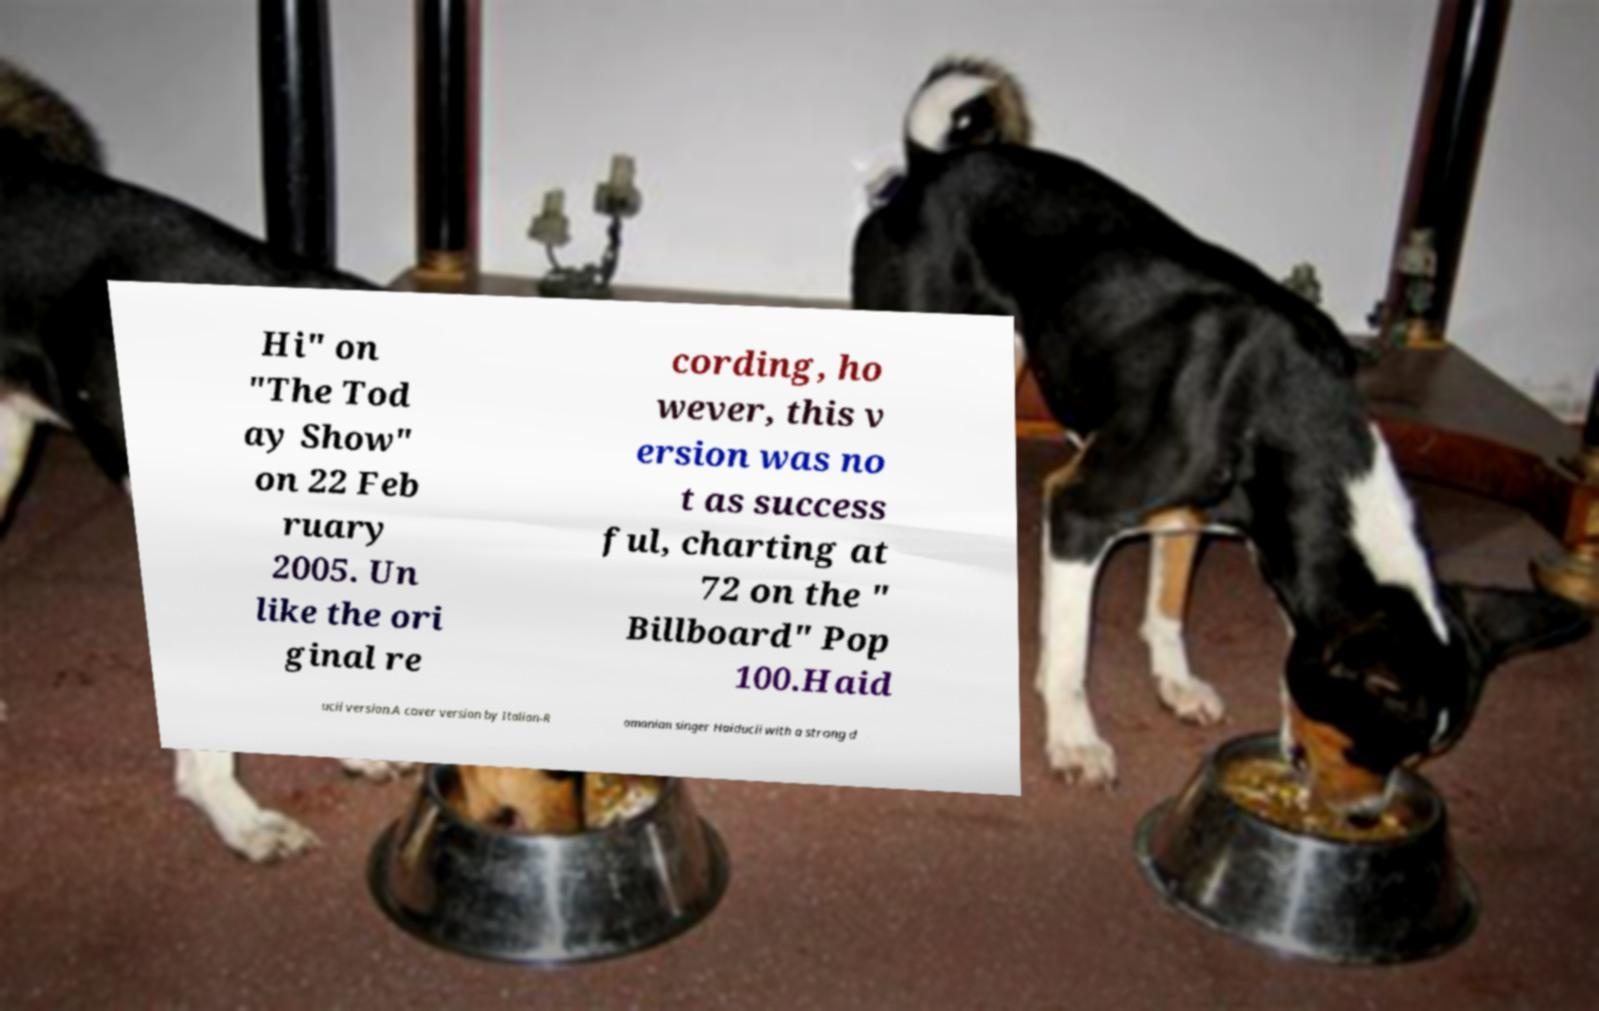There's text embedded in this image that I need extracted. Can you transcribe it verbatim? Hi" on "The Tod ay Show" on 22 Feb ruary 2005. Un like the ori ginal re cording, ho wever, this v ersion was no t as success ful, charting at 72 on the " Billboard" Pop 100.Haid ucii version.A cover version by Italian-R omanian singer Haiducii with a strong d 